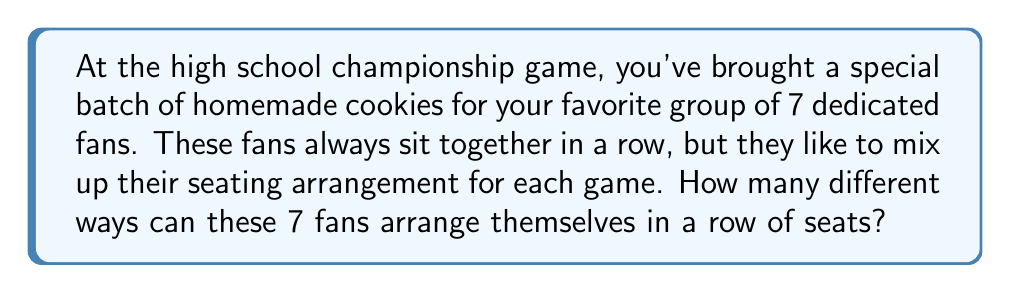Provide a solution to this math problem. Let's approach this step-by-step:

1) This is a permutation problem. We need to arrange 7 distinct people in a line.

2) For the first seat, we have 7 choices, as any of the 7 fans can sit there.

3) After the first person is seated, we have 6 choices for the second seat.

4) For the third seat, we'll have 5 choices, and so on.

5) This process continues until we reach the last seat, where we'll have only 1 choice left.

6) The multiplication principle states that if we have a series of choices, where the number of choices for each decision is independent of the other choices, we multiply the number of possibilities for each choice.

7) Therefore, the total number of possible arrangements is:

   $$7 \times 6 \times 5 \times 4 \times 3 \times 2 \times 1$$

8) This is also known as 7 factorial, written as 7!

9) Let's calculate this:
   $$7! = 7 \times 6 \times 5 \times 4 \times 3 \times 2 \times 1 = 5040$$

Thus, there are 5040 different ways for the 7 fans to arrange themselves in a row.
Answer: $5040$ 